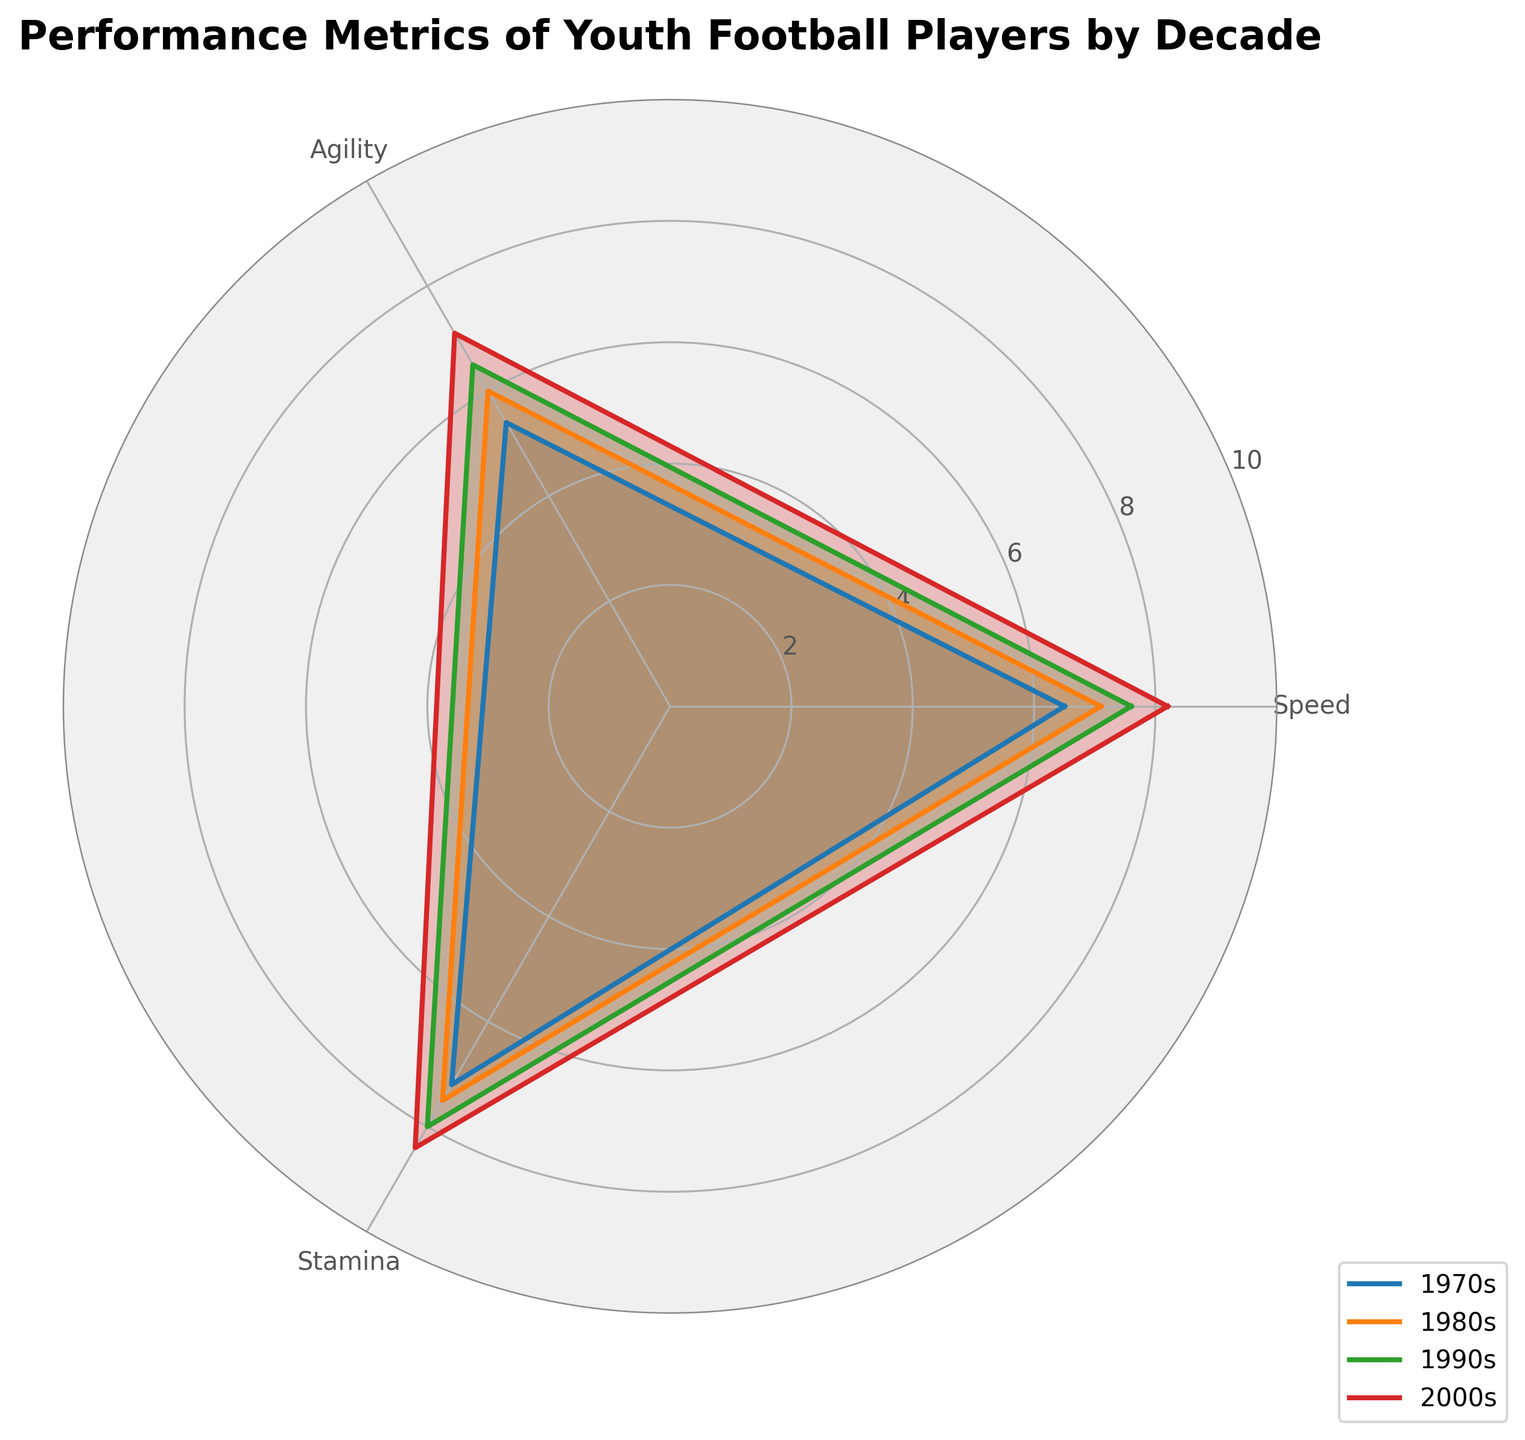what is the title of the radar chart? The title is written at the top center of the chart. It reads "Performance Metrics of Youth Football Players by Decade."
Answer: Performance Metrics of Youth Football Players by Decade How many decades are compared in the chart? Each decade's data is a separate line on the chart. There are four lines corresponding to four decades: 1970s, 1980s, 1990s, 2000s.
Answer: Four Which decade has the highest speed? Look at the points for 'Speed' on the radial axis for each decade. The 2000s have the highest value at 8.2.
Answer: 2000s What is the difference in agility between the 1970s and 2000s? The agility value for the 1970s is 5.4, and for the 2000s, it is 7.1. Subtract 5.4 from 7.1 to get the difference.
Answer: 1.7 Which performance metric shows the most improvement from the 1970s to the 2000s? Compare the differences for Speed (8.2-6.5=1.7), Agility (7.1-5.4=1.7), and Stamina (8.4-7.2=1.2). The greatest difference is 1.7 for both Speed and Agility.
Answer: Speed and Agility What is the average stamina across all decades? Sum the stamina values for all decades (7.2 + 7.5 + 8.0 + 8.4 = 31.1) and divide by the number of decades (4). The average is 31.1 / 4.
Answer: 7.775 How does the stamina of the 1980s compare to the 2000s? The stamina value for the 1980s is 7.5, and for the 2000s, it is 8.4. The 2000s have a higher stamina value.
Answer: Higher in 2000s Which decade has the lowest weighted average across all metrics? Calculate the weighted average for each decade. 
1970s: (6.5 + 5.4 + 7.2) / 3 = 6.37
1980s: (7.1 + 6.0 + 7.5) / 3 = 6.87
1990s: (7.6 + 6.5 + 8.0) / 3 = 7.37
2000s: (8.2 + 7.1 + 8.4) / 3 = 7.9
The 1970s have the lowest weighted average at 6.37.
Answer: 1970s For which metric do the youth football players show the least improvement over the decades? Compare the increase in values from 1970s to 2000s for all metrics: Speed (8.2 - 6.5 = 1.7), Agility (7.1 - 5.4 = 1.7), Stamina (8.4 - 7.2 = 1.2). The least improvement is seen in Stamina.
Answer: Stamina 